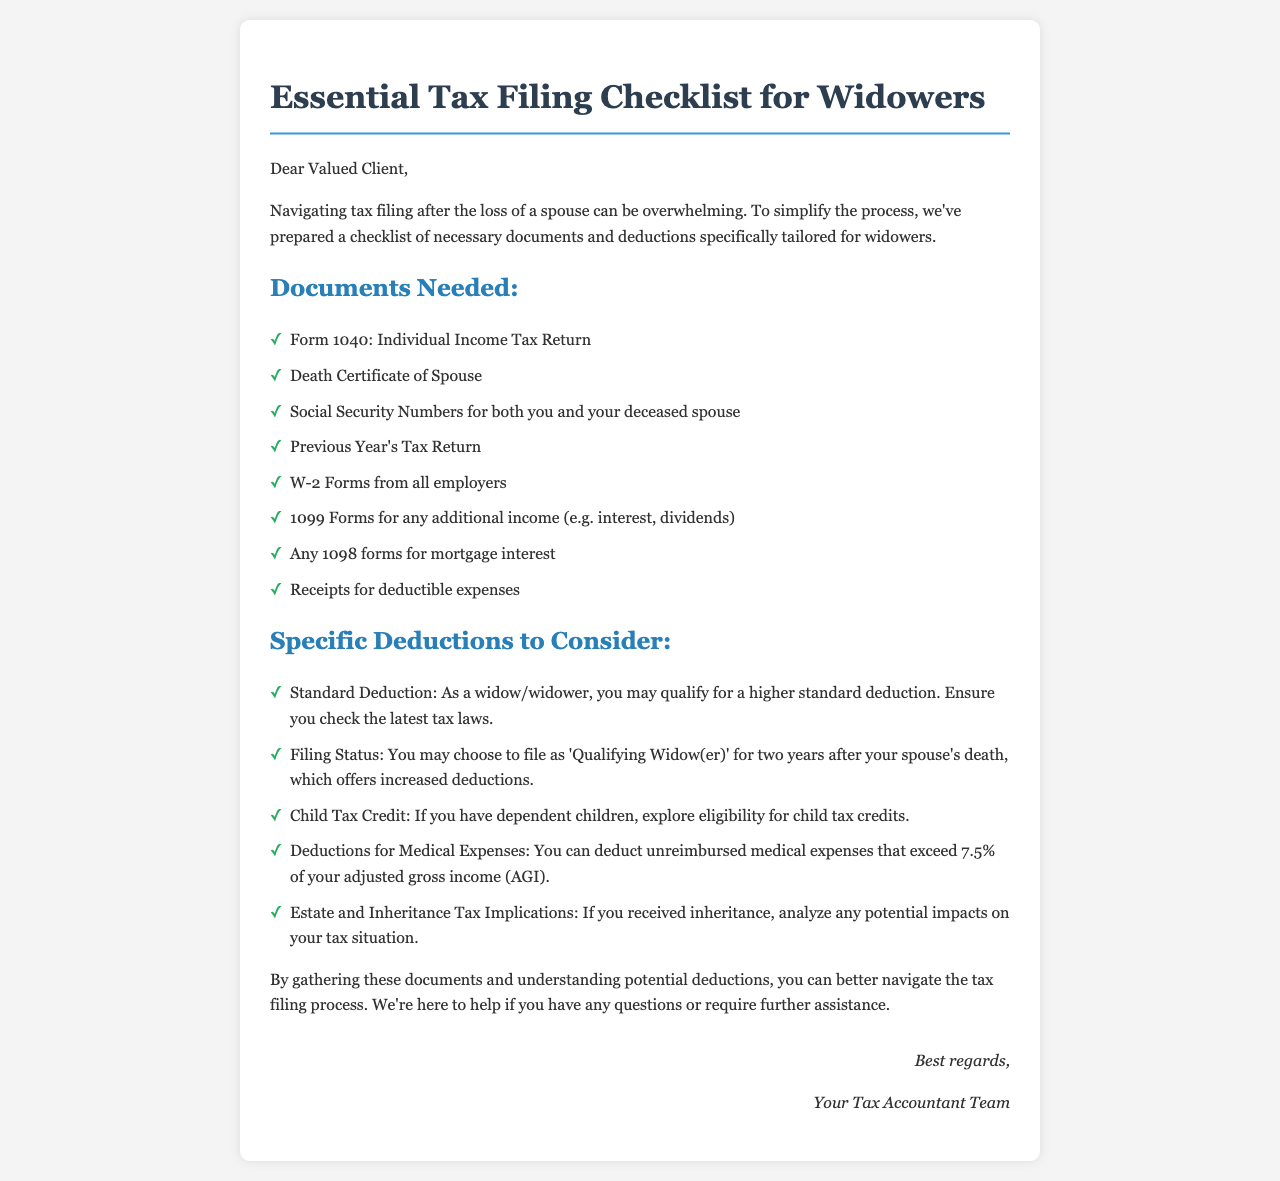What is the main purpose of the document? The document aims to provide a checklist of necessary documents and deductions specifically tailored for widowers to simplify tax filing.
Answer: Simplify tax filing What form is needed to file taxes? The document mentions a specific form required for tax filing, which is a standard form for individual income tax returns.
Answer: Form 1040 What type of income documents are required? The document lists two specific forms that provide information regarding income from employers and additional sources.
Answer: W-2 Forms and 1099 Forms What is the higher standard deduction eligibility for widowers? The document specifies that widowers may qualify for a specific tax deduction, which is relevant to their filing status.
Answer: Higher standard deduction How long can a widower file as 'Qualifying Widow(er)'? The document mentions a time frame after the spouse's death during which the filing status can be chosen.
Answer: Two years What can be deducted if the unreimbursed medical expenses exceed a certain percentage? The document provides information regarding the condition under which medical expenses can be deducted based on a specific ratio related to income.
Answer: 7.5% of AGI What additional credit may be available if there are dependent children? The document highlights a specific tax credit that may apply in the presence of dependent children, which is designed to provide financial relief.
Answer: Child Tax Credit What important certificate is required among the documents? The document states that a specific document is necessary related to the deceased spouse.
Answer: Death Certificate What should individuals be aware of regarding estate and inheritance? The document encourages analysis of tax implications regarding a specific financial aspect following a spouse's passing.
Answer: Tax Implications 